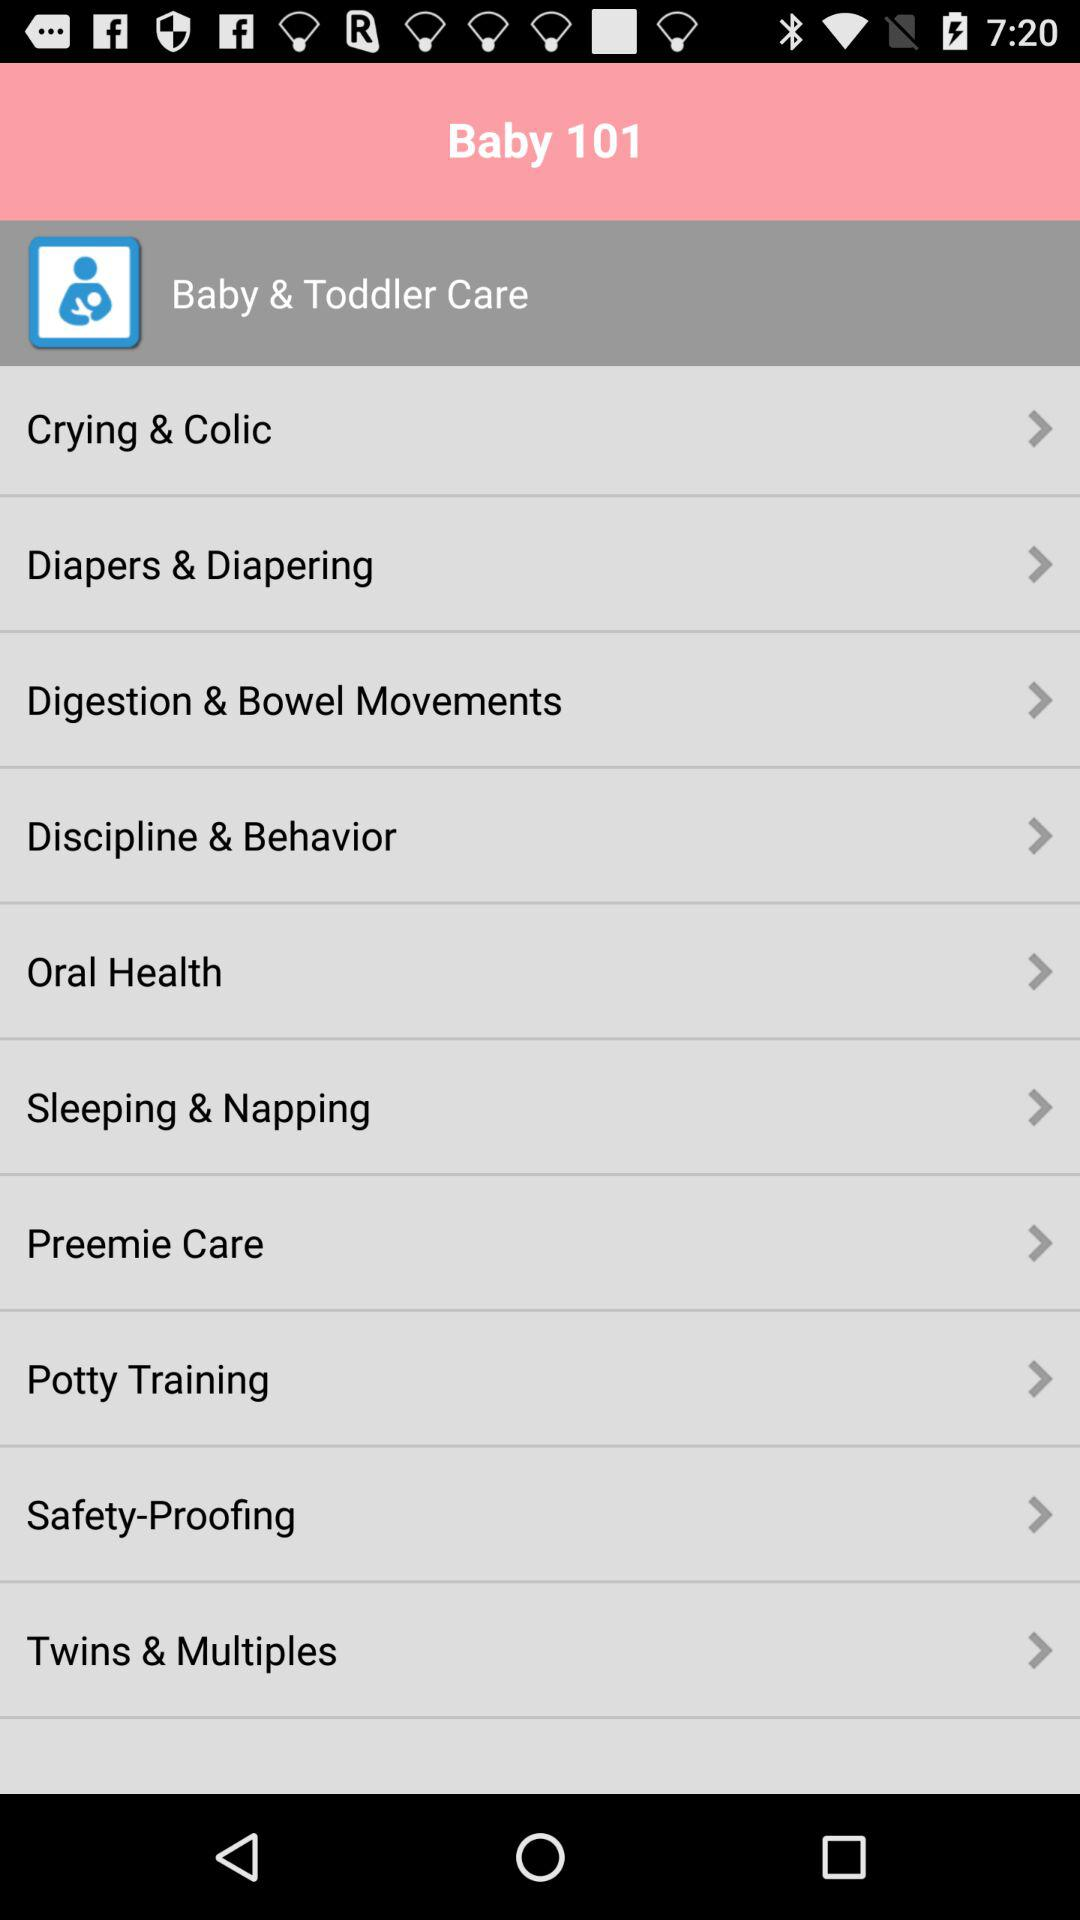What is the application name? The application name is "Baby 101". 